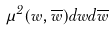<formula> <loc_0><loc_0><loc_500><loc_500>\mu ^ { 2 } ( w , \overline { w } ) d w d \overline { w }</formula> 